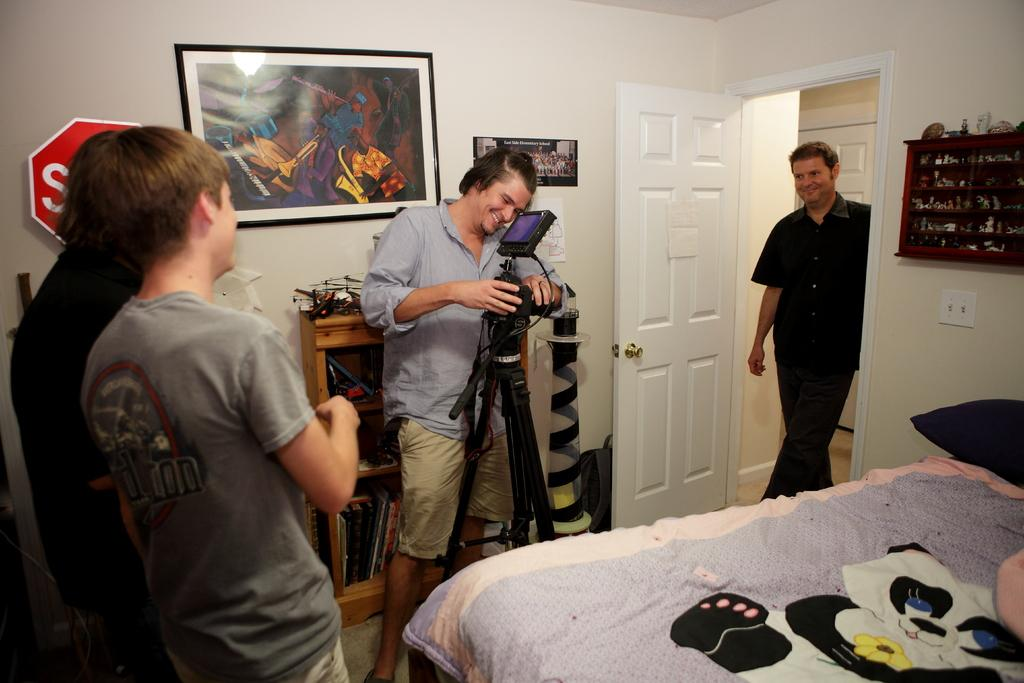How many people are in the image? There is a group of people standing in the image. What surface are the people standing on? The people are standing on the floor. What can be seen in the background of the image? There is a door visible in the image. Is there any decoration or item on the wall in the image? Yes, there is a photo on a wall in the image. What type of ball is being used for the discussion in the image? There is no ball or discussion present in the image; it features a group of people standing on the floor with a door and a photo on the wall. 